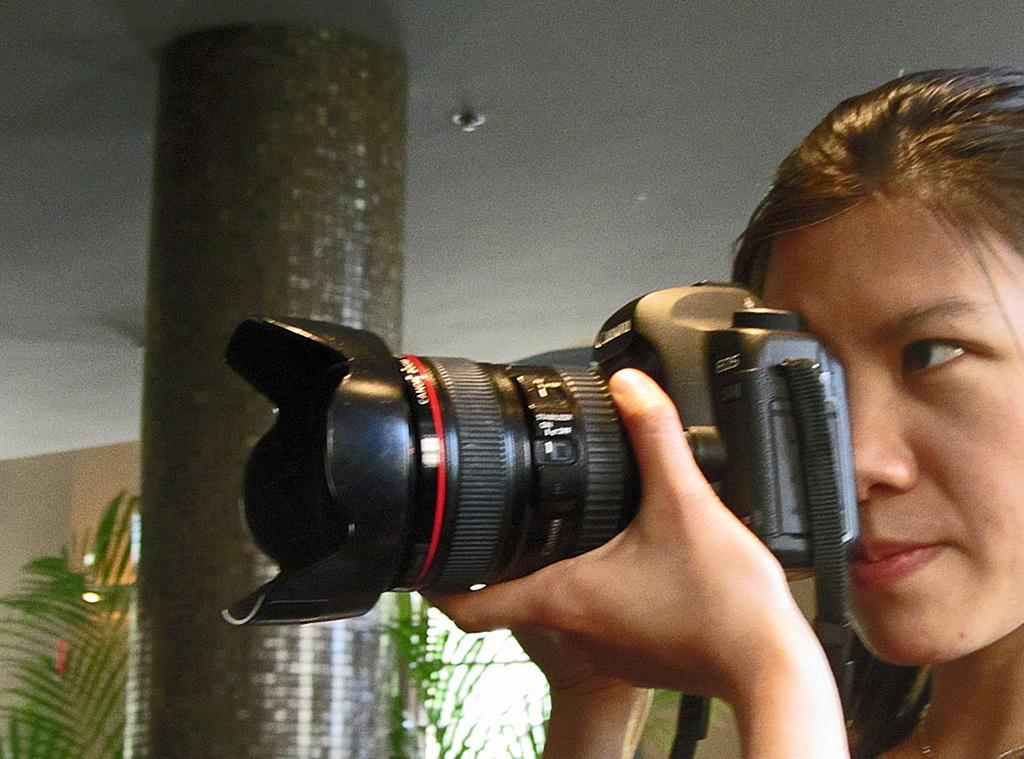Who is the main subject in the image? There is a woman in the image. What is the woman holding in the image? The woman is holding a camera. What can be seen in the background of the image? There is a pillar, trees, and a roof visible in the background of the image. What type of dress is the woman wearing in the image? The provided facts do not mention the type of dress the woman is wearing, so we cannot answer this question definitively. 